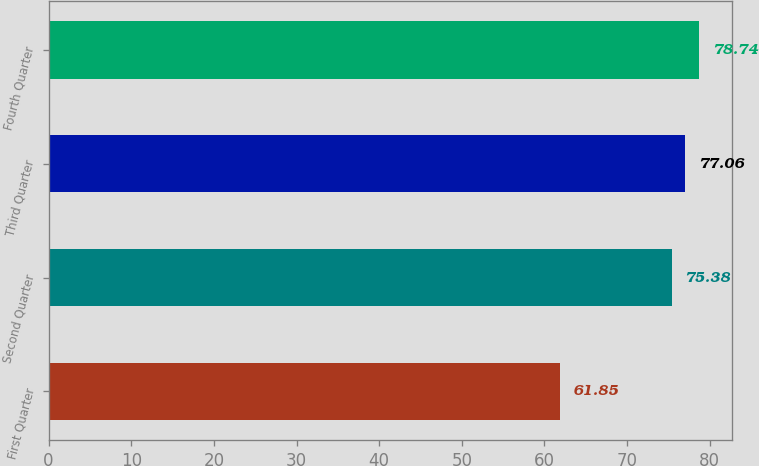Convert chart. <chart><loc_0><loc_0><loc_500><loc_500><bar_chart><fcel>First Quarter<fcel>Second Quarter<fcel>Third Quarter<fcel>Fourth Quarter<nl><fcel>61.85<fcel>75.38<fcel>77.06<fcel>78.74<nl></chart> 